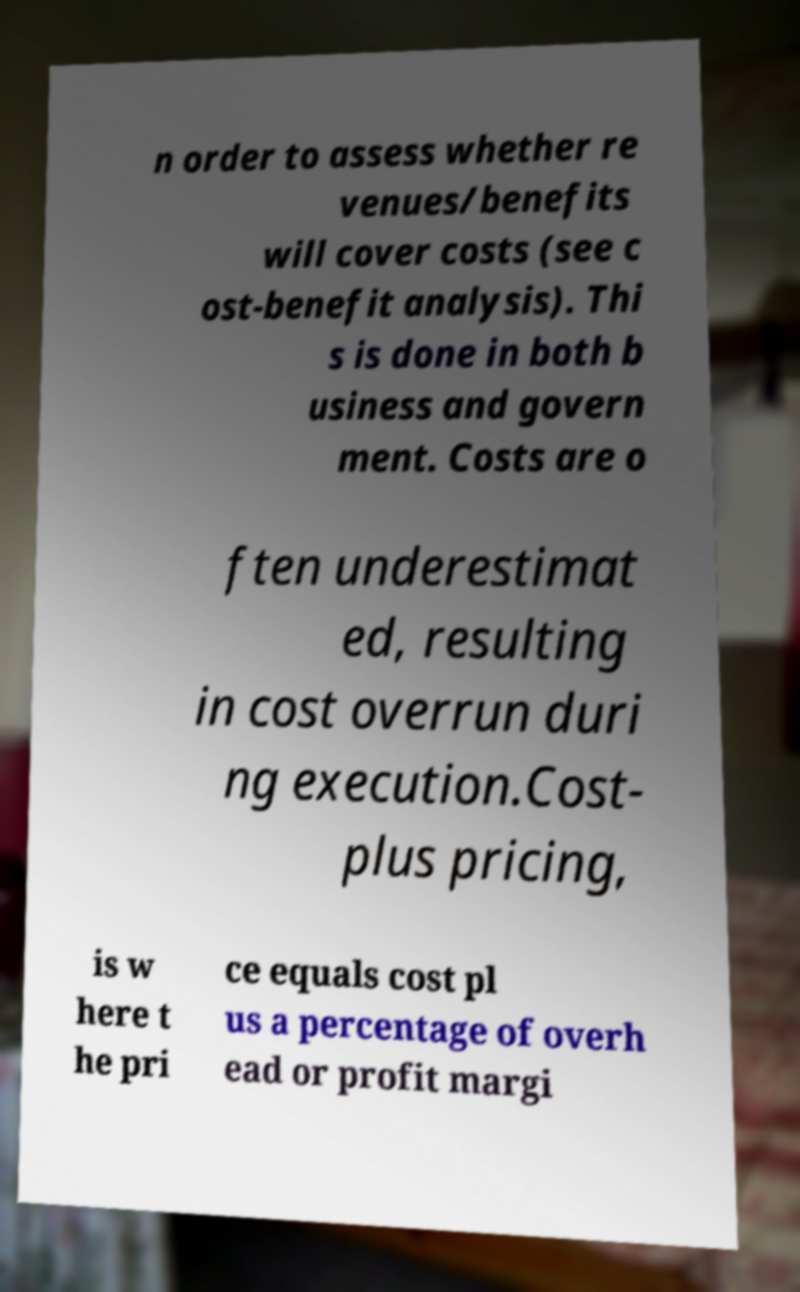Please identify and transcribe the text found in this image. n order to assess whether re venues/benefits will cover costs (see c ost-benefit analysis). Thi s is done in both b usiness and govern ment. Costs are o ften underestimat ed, resulting in cost overrun duri ng execution.Cost- plus pricing, is w here t he pri ce equals cost pl us a percentage of overh ead or profit margi 